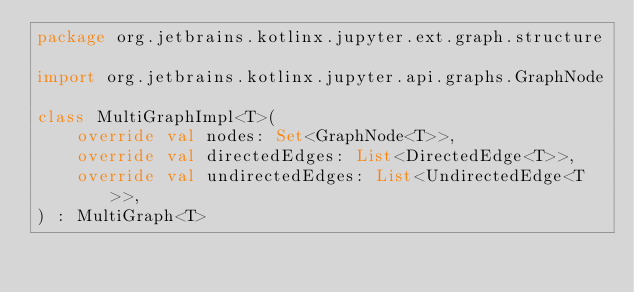<code> <loc_0><loc_0><loc_500><loc_500><_Kotlin_>package org.jetbrains.kotlinx.jupyter.ext.graph.structure

import org.jetbrains.kotlinx.jupyter.api.graphs.GraphNode

class MultiGraphImpl<T>(
    override val nodes: Set<GraphNode<T>>,
    override val directedEdges: List<DirectedEdge<T>>,
    override val undirectedEdges: List<UndirectedEdge<T>>,
) : MultiGraph<T>
</code> 